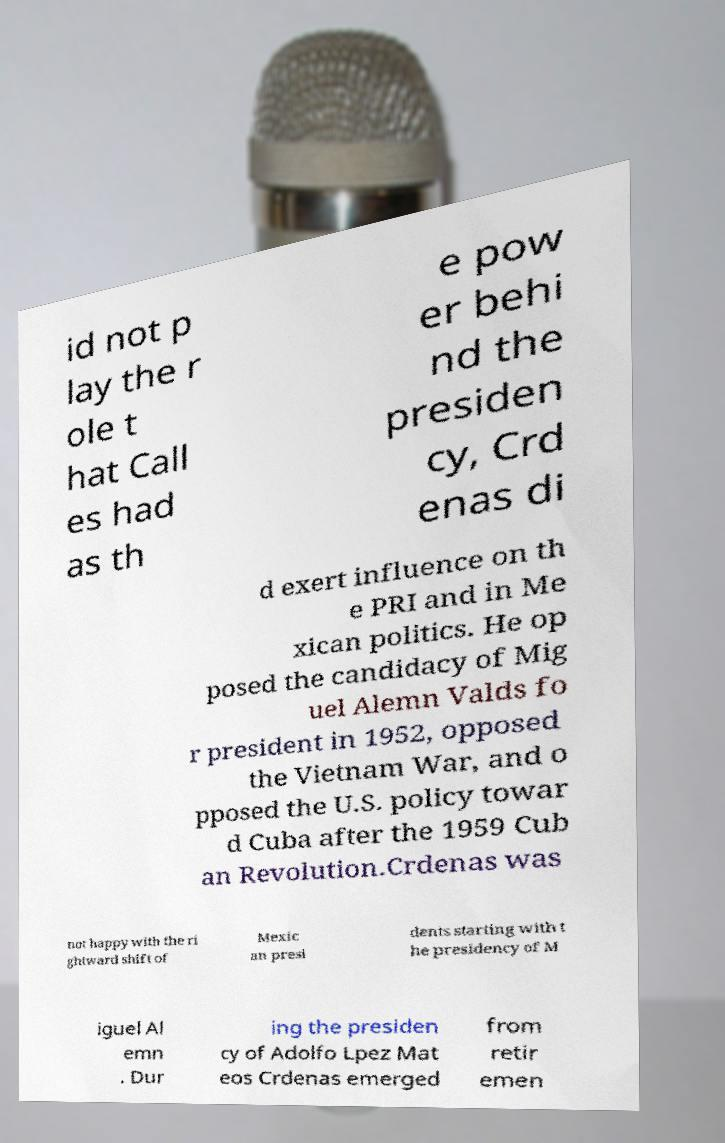Can you accurately transcribe the text from the provided image for me? id not p lay the r ole t hat Call es had as th e pow er behi nd the presiden cy, Crd enas di d exert influence on th e PRI and in Me xican politics. He op posed the candidacy of Mig uel Alemn Valds fo r president in 1952, opposed the Vietnam War, and o pposed the U.S. policy towar d Cuba after the 1959 Cub an Revolution.Crdenas was not happy with the ri ghtward shift of Mexic an presi dents starting with t he presidency of M iguel Al emn . Dur ing the presiden cy of Adolfo Lpez Mat eos Crdenas emerged from retir emen 